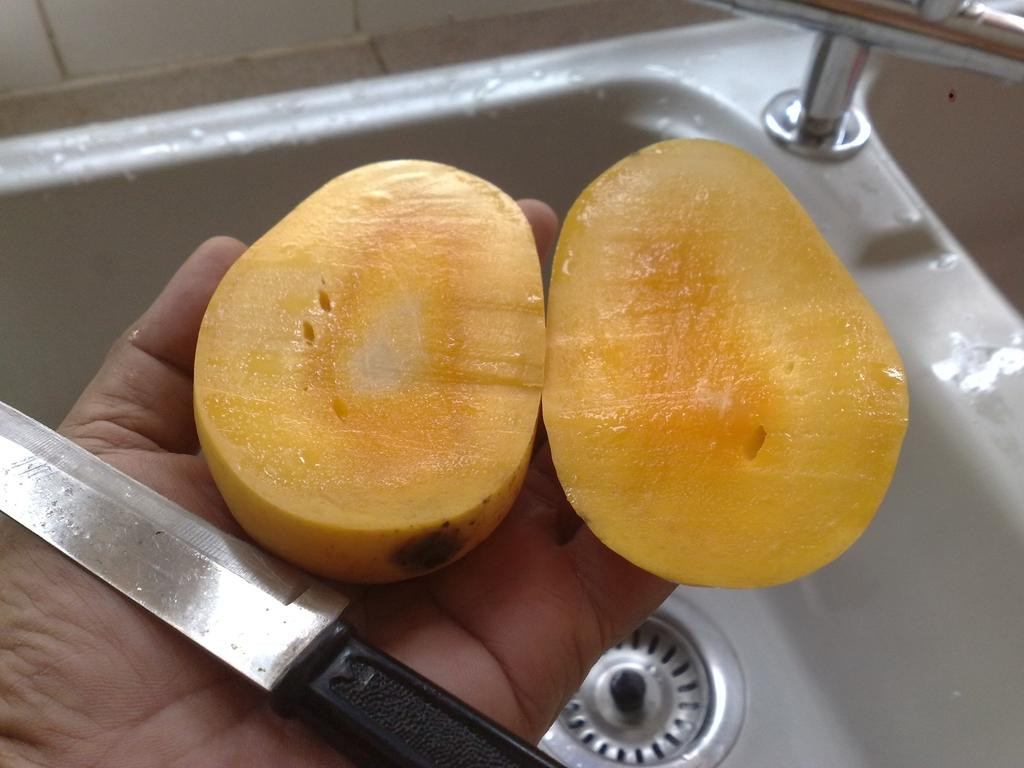What fruit is present in the image? There is a mango in the image. What object is being used in the image? There is a knife in the image, and it is being held by a person. What can be seen in the background of the image? There is a sink and a tap in the background of the image, along with other objects. What type of church can be seen in the background of the image? There is no church present in the image; the background features a sink, tap, and other objects. Who is the creator of the mango in the image? The mango is a natural fruit and is not created by a person, so there is no specific creator to mention. 